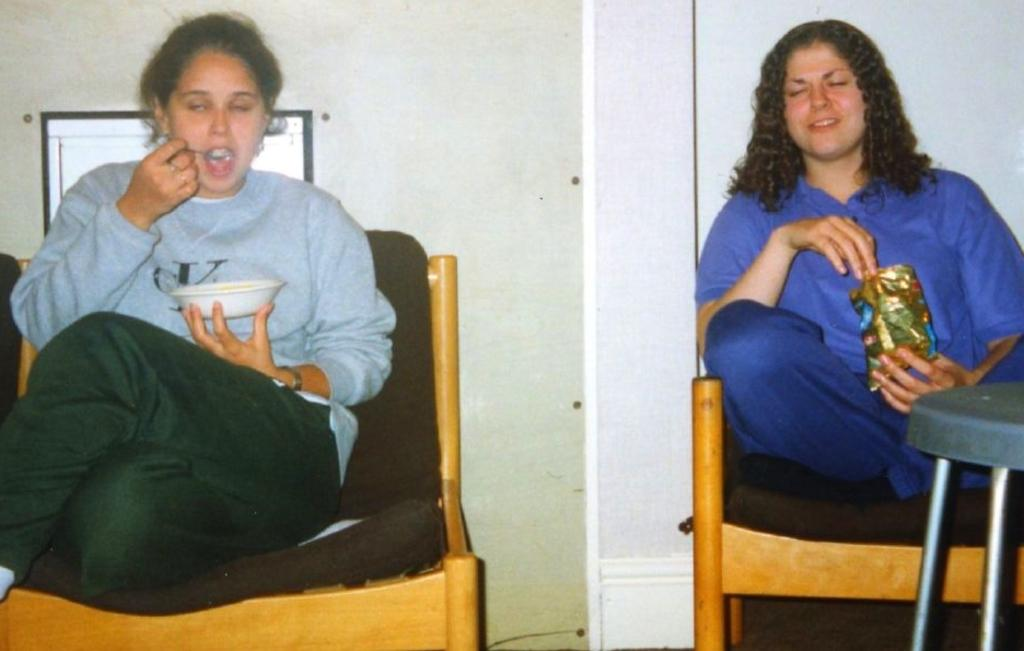How many people are in the image? There are two people in the image. What are the people doing in the image? The two people are seated on chairs and eating. What type of pipe is being used by the people in the image? There is no pipe present in the image. What committee is the people in the image a part of? There is no information about a committee in the image. 